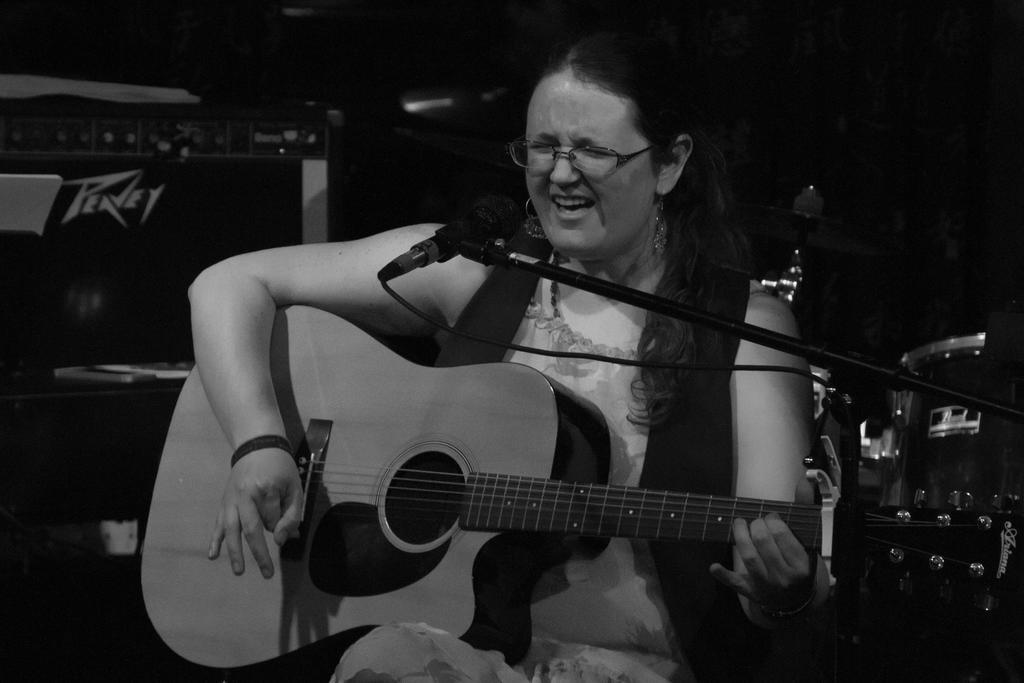Who is the main subject in the image? There is a woman in the image. What is the woman doing in the image? The woman is singing and playing a guitar. What object is in front of the woman? There is a microphone in front of the woman. What type of tent can be seen in the background of the image? There is no tent present in the image; it features a woman singing and playing a guitar with a microphone in front of her. 